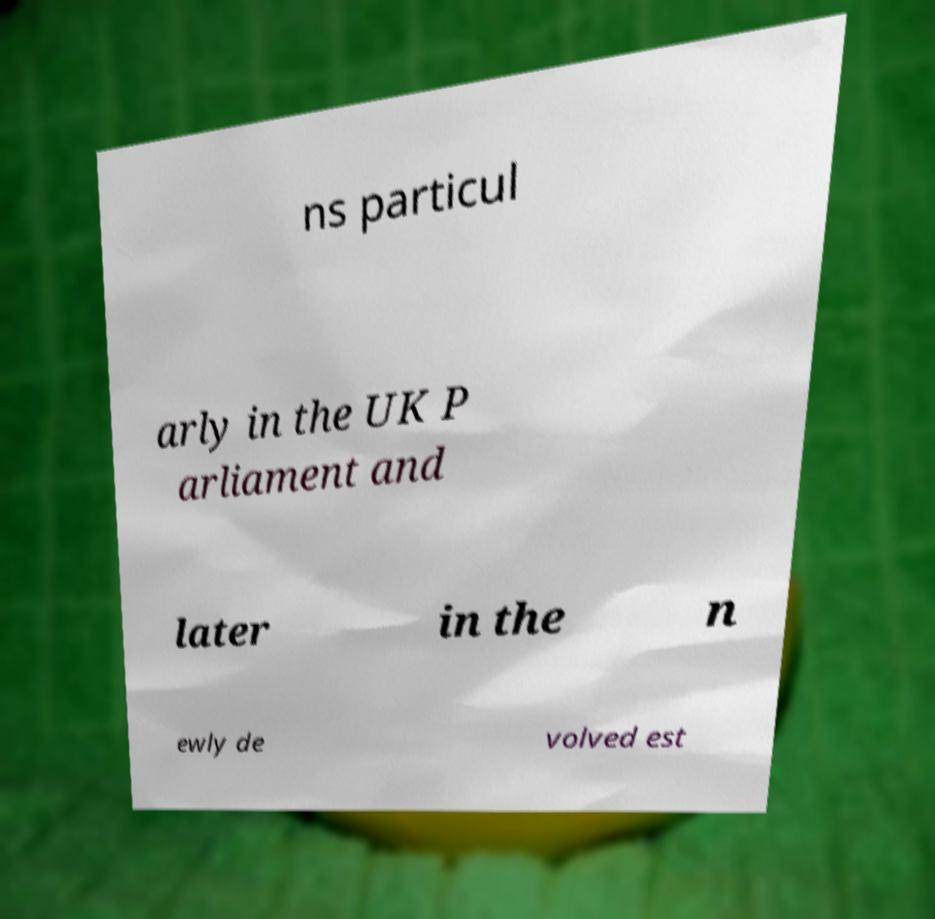Please identify and transcribe the text found in this image. ns particul arly in the UK P arliament and later in the n ewly de volved est 